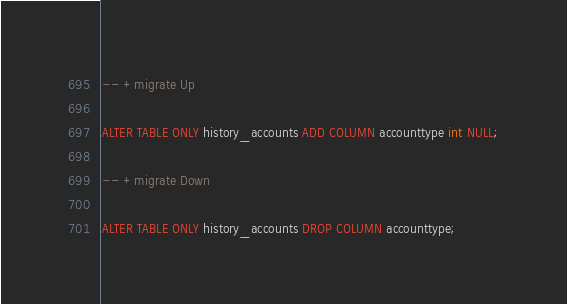Convert code to text. <code><loc_0><loc_0><loc_500><loc_500><_SQL_>-- +migrate Up

ALTER TABLE ONLY history_accounts ADD COLUMN accounttype int NULL;

-- +migrate Down

ALTER TABLE ONLY history_accounts DROP COLUMN accounttype;
</code> 